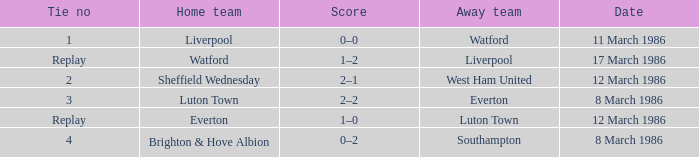What tie happened with Southampton? 4.0. 